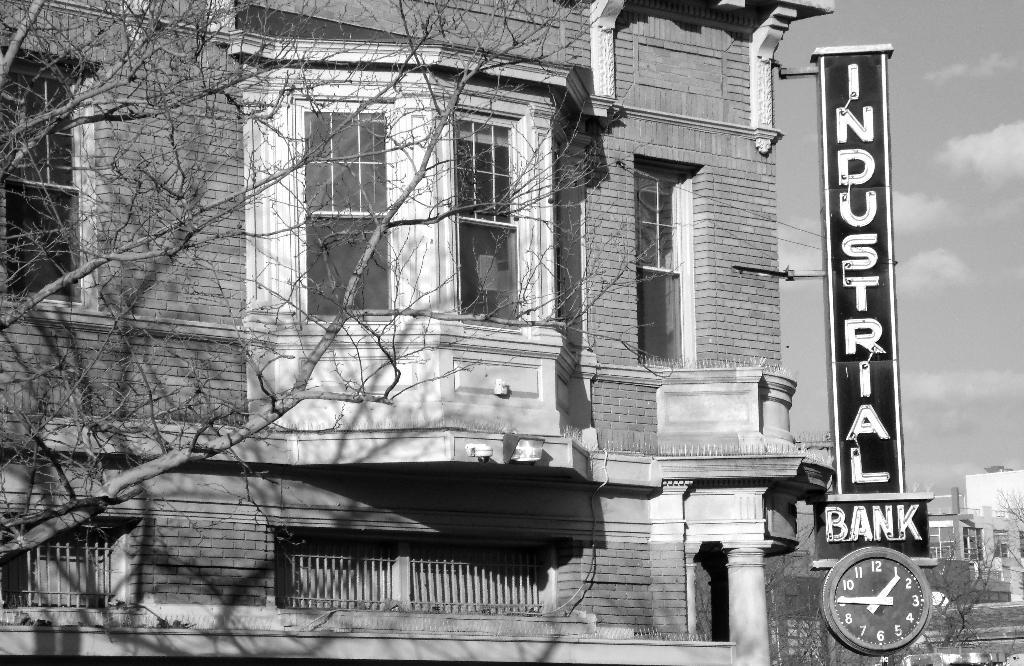<image>
Give a short and clear explanation of the subsequent image. The Industrial Bank has a clock attached to its outdoor sign. 